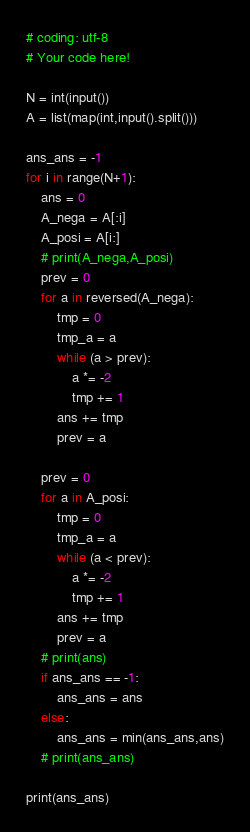<code> <loc_0><loc_0><loc_500><loc_500><_Python_># coding: utf-8
# Your code here!

N = int(input())
A = list(map(int,input().split()))

ans_ans = -1
for i in range(N+1):
    ans = 0
    A_nega = A[:i]
    A_posi = A[i:]
    # print(A_nega,A_posi)
    prev = 0
    for a in reversed(A_nega):
        tmp = 0
        tmp_a = a
        while (a > prev):
            a *= -2
            tmp += 1
        ans += tmp
        prev = a
        
    prev = 0
    for a in A_posi:
        tmp = 0
        tmp_a = a
        while (a < prev):
            a *= -2
            tmp += 1
        ans += tmp
        prev = a
    # print(ans)
    if ans_ans == -1:
        ans_ans = ans
    else:
        ans_ans = min(ans_ans,ans)
    # print(ans_ans)
        
print(ans_ans)</code> 